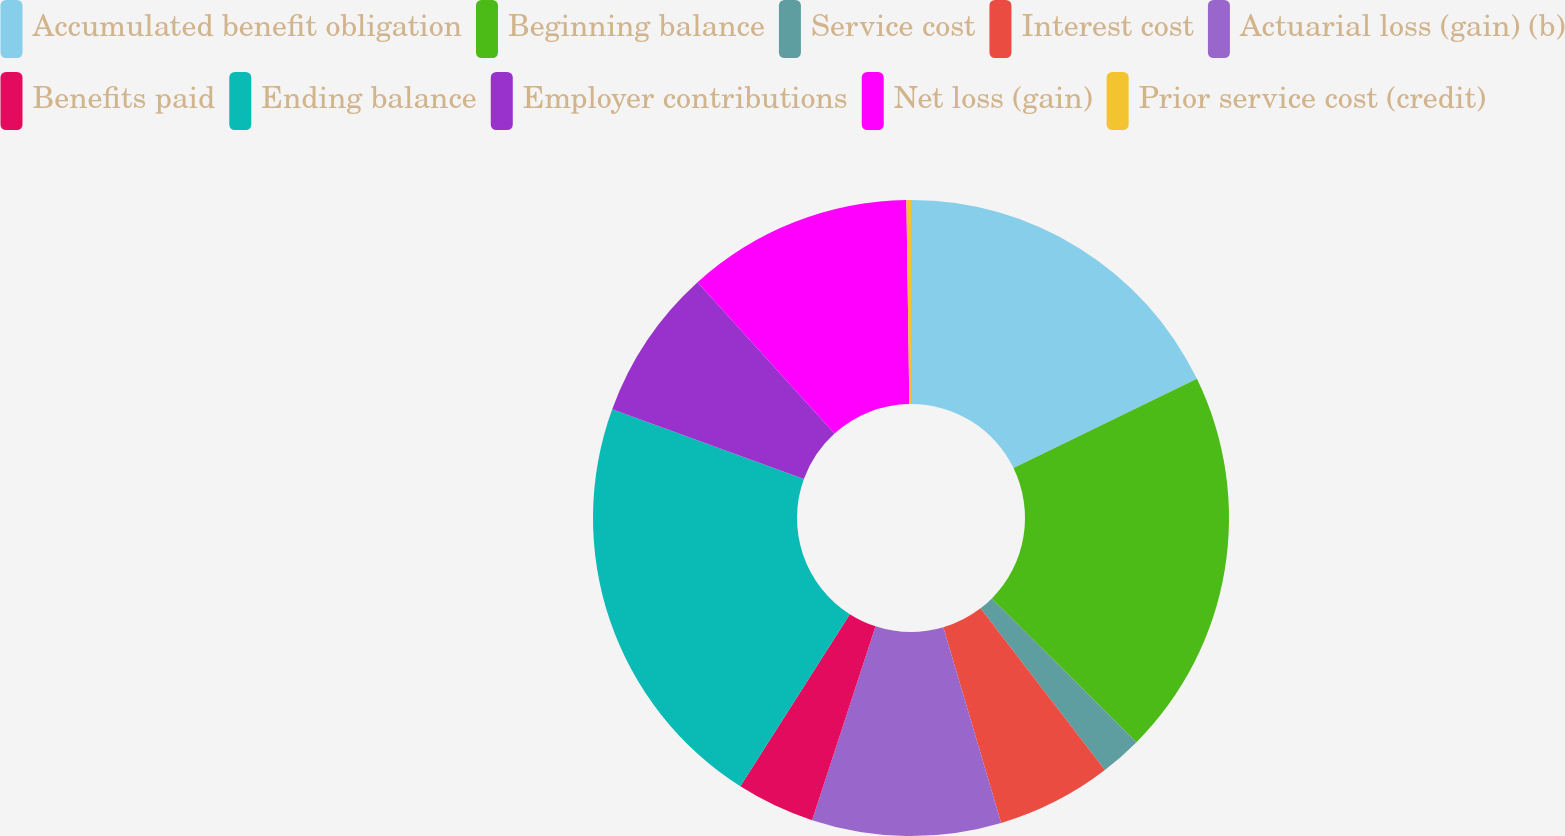<chart> <loc_0><loc_0><loc_500><loc_500><pie_chart><fcel>Accumulated benefit obligation<fcel>Beginning balance<fcel>Service cost<fcel>Interest cost<fcel>Actuarial loss (gain) (b)<fcel>Benefits paid<fcel>Ending balance<fcel>Employer contributions<fcel>Net loss (gain)<fcel>Prior service cost (credit)<nl><fcel>17.79%<fcel>19.66%<fcel>2.11%<fcel>5.86%<fcel>9.61%<fcel>3.98%<fcel>21.54%<fcel>7.73%<fcel>11.48%<fcel>0.23%<nl></chart> 